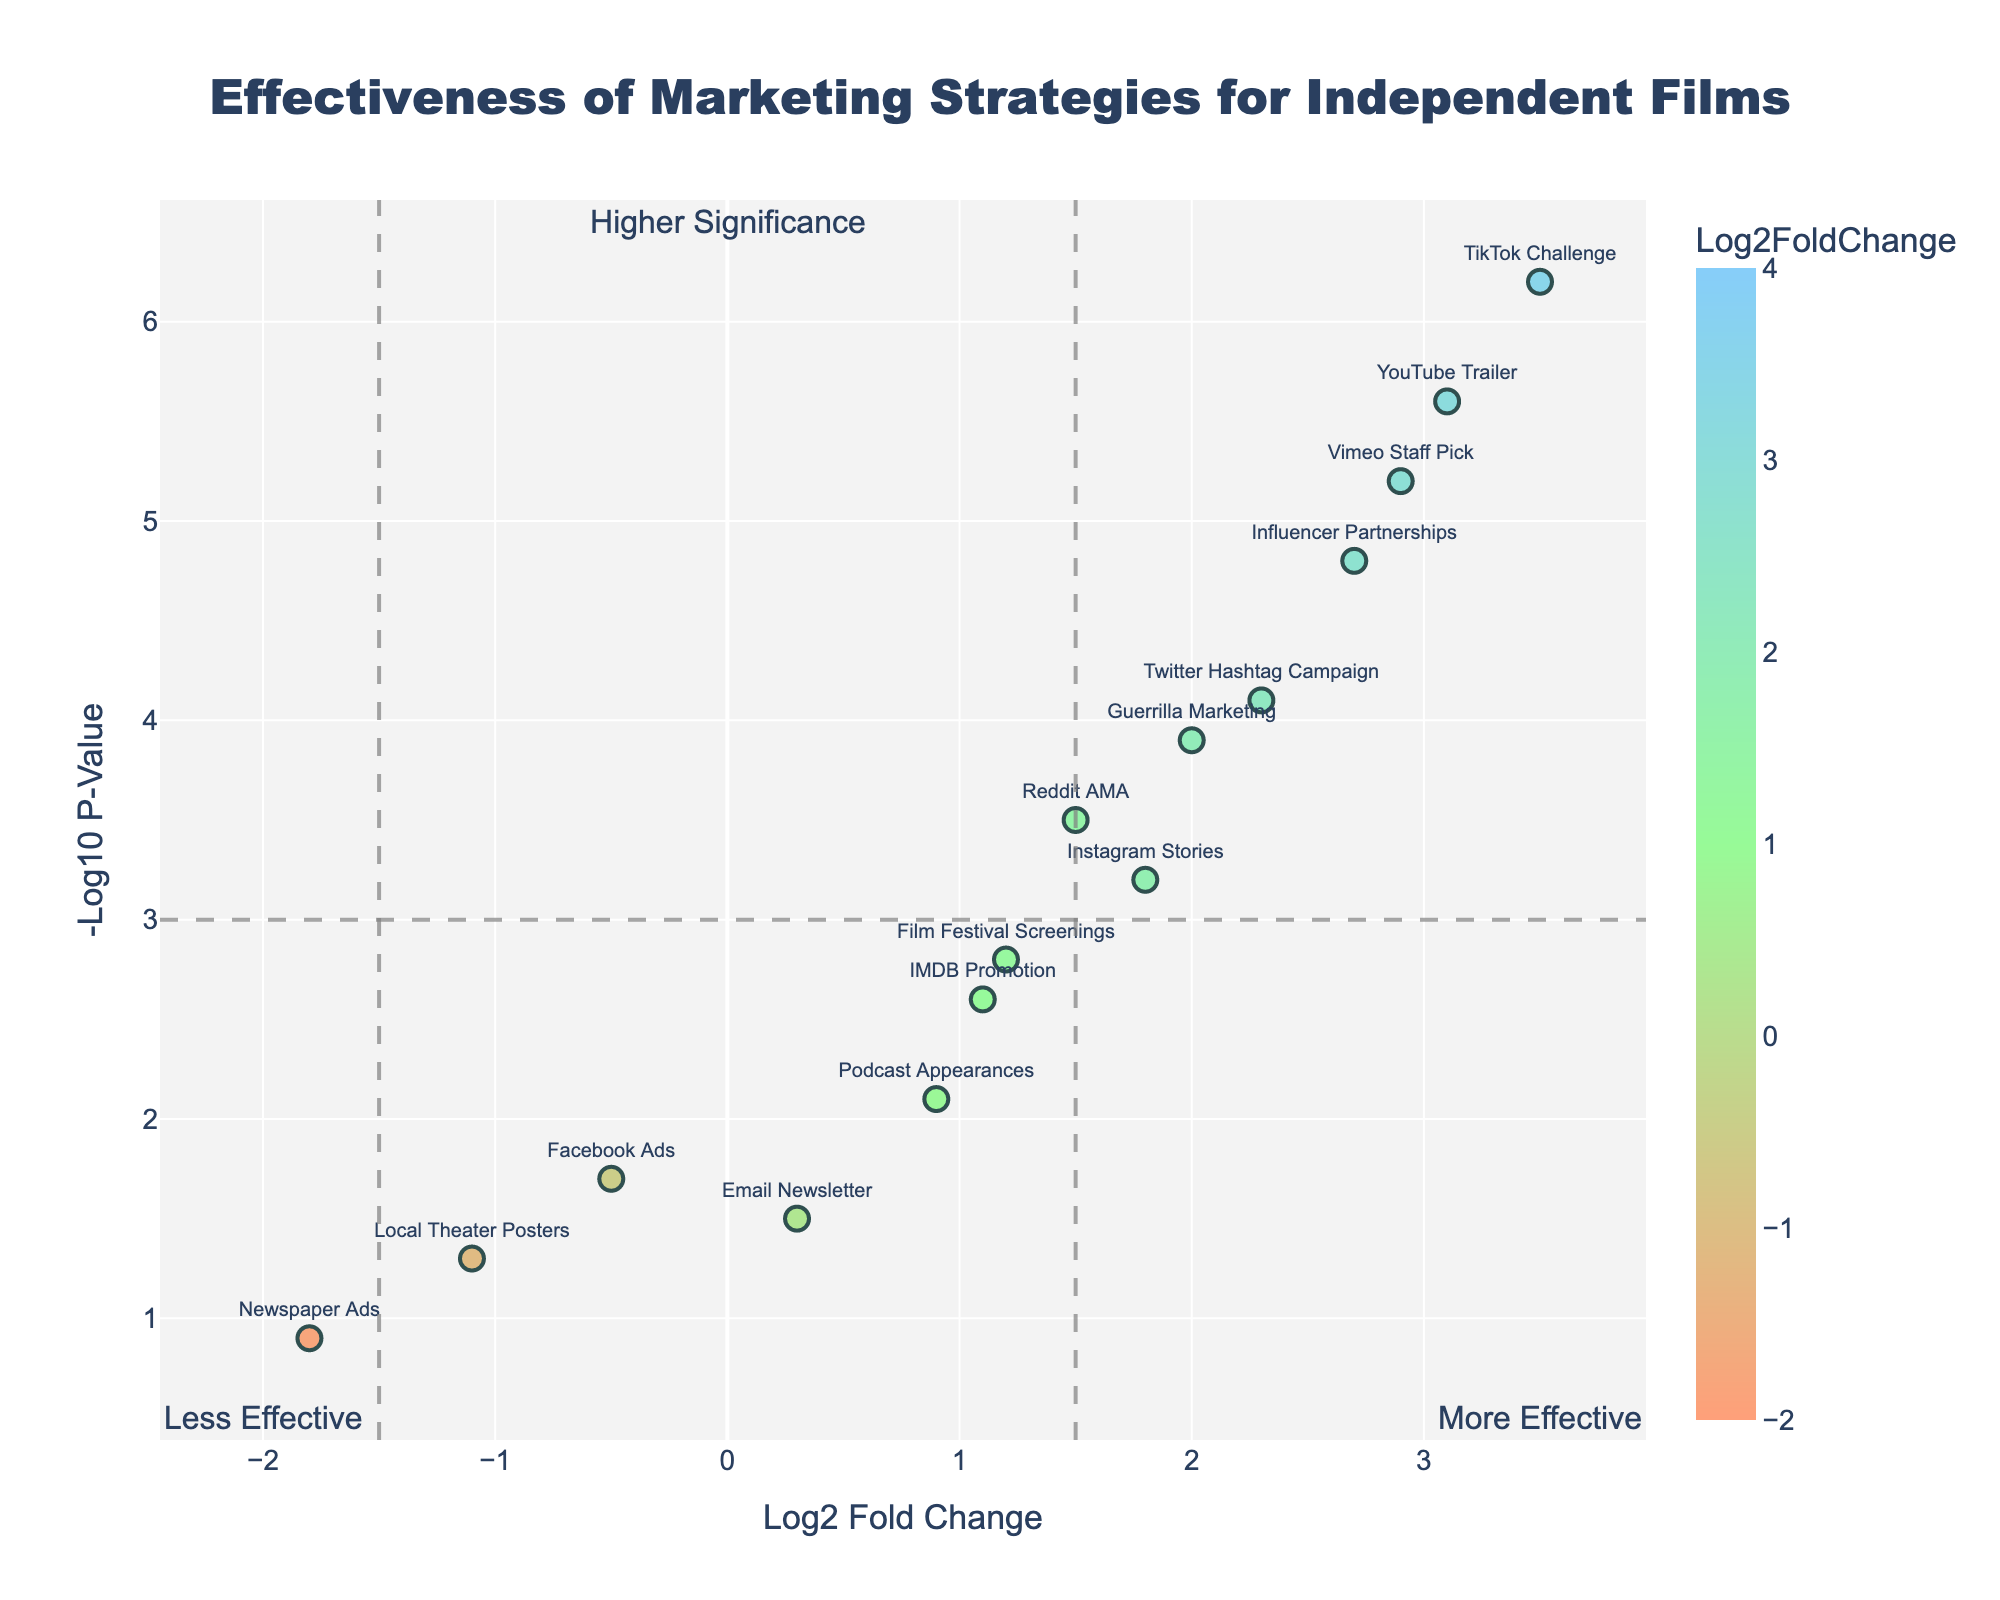How many marketing strategies are depicted in the plot? Count the number of unique data points plotted on the graph. Each point represents a different marketing strategy.
Answer: 15 What marketing strategy shows the highest Log2 Fold Change value? Look for the point positioned furthest to the right on the horizontal axis (Log2 Fold Change).
Answer: TikTok Challenge Which marketing strategy has the lowest significance? Find the point with the lowest position (closest to the x-axis) on the vertical axis (-Log10 P-Value).
Answer: Newspaper Ads Which strategy is more effective: "Facebook Ads" or "Instagram Stories"? Compare the Log2 Fold Change values of both strategies. The strategy with the higher positive value is more effective.
Answer: Instagram Stories How many strategies have a Log2 Fold Change less than -1? Count the number of points that lie to the left of -1 on the horizontal axis.
Answer: 2 Which strategy has the highest significance while being highly effective? Look for the point positioned highest on the vertical axis (highest -Log10 P-Value) and also furthest to the right on the horizontal axis.
Answer: TikTok Challenge Compare the effectiveness between "YouTube Trailer" and "Local Theater Posters". Which one is more effective? Find both points on the plot and compare their positions on the horizontal axis. The one further to the right is more effective.
Answer: YouTube Trailer Among "Twitter Hashtag Campaign", "Influencer Partnerships", and "Guerrilla Marketing", which is the most significant? Compare the vertical positions of these points on the axis (-Log10 P-Value). The highest point is the most significant.
Answer: Influencer Partnerships Is "Email Newsletter" a significant strategy based on the plot? Check if the point for "Email Newsletter" is above the horizontal threshold line representing -Log10 P-Value of 3.
Answer: No Does the plot indicate that traditional advertising methods are generally less effective than social media strategies? Compare the positioning of categories: points representing traditional methods (e.g., Newspaper Ads, Local Theater Posters) vs. social media strategies. Social media strategies are generally to the right (higher Log2 Fold Change) and upwards (higher -Log10 P-Value).
Answer: Yes 